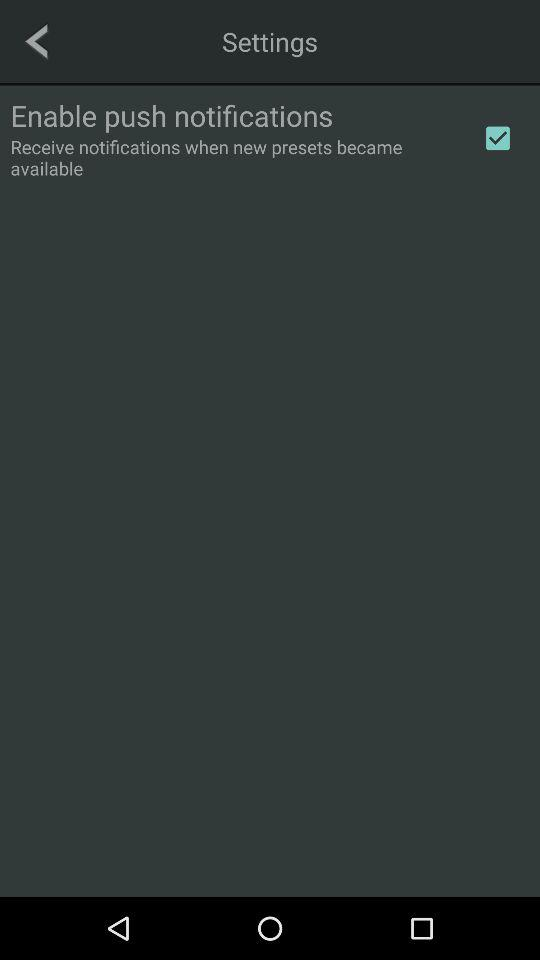What is the version of the application?
When the provided information is insufficient, respond with <no answer>. <no answer> 